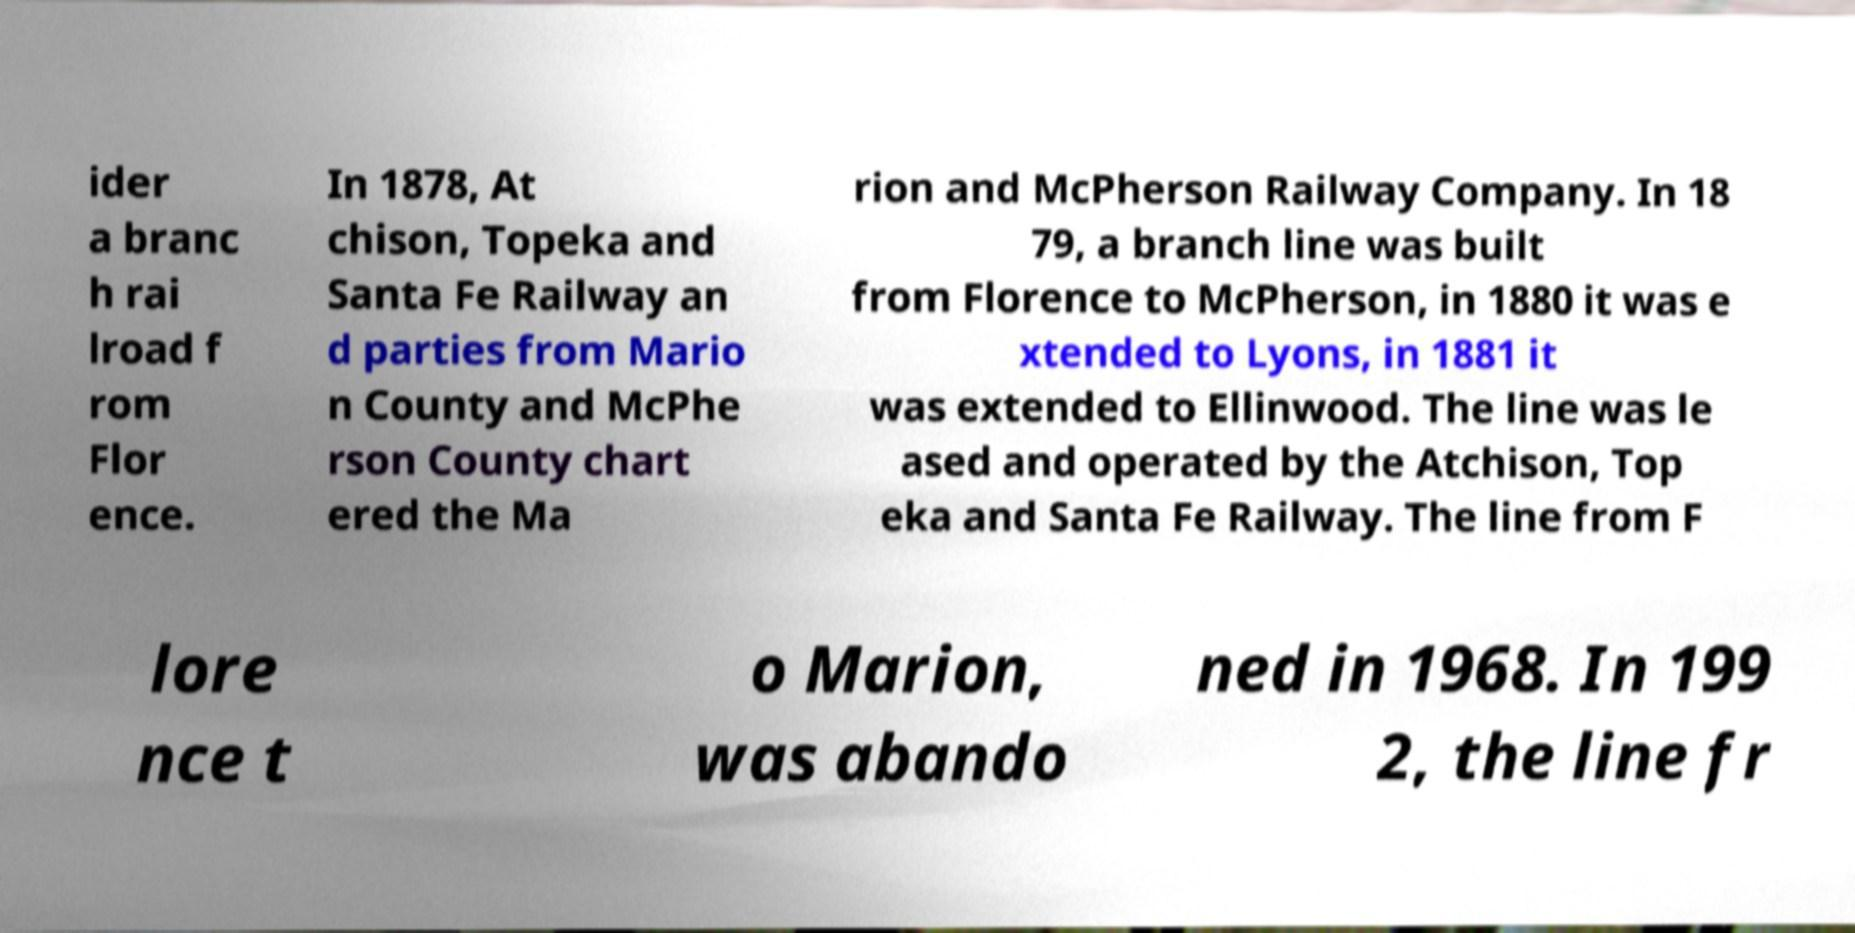Could you extract and type out the text from this image? ider a branc h rai lroad f rom Flor ence. In 1878, At chison, Topeka and Santa Fe Railway an d parties from Mario n County and McPhe rson County chart ered the Ma rion and McPherson Railway Company. In 18 79, a branch line was built from Florence to McPherson, in 1880 it was e xtended to Lyons, in 1881 it was extended to Ellinwood. The line was le ased and operated by the Atchison, Top eka and Santa Fe Railway. The line from F lore nce t o Marion, was abando ned in 1968. In 199 2, the line fr 